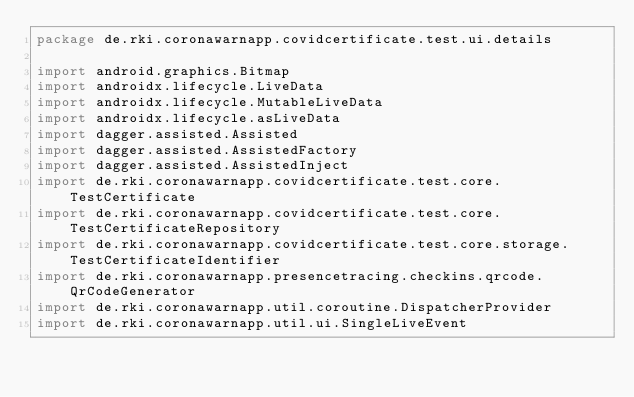Convert code to text. <code><loc_0><loc_0><loc_500><loc_500><_Kotlin_>package de.rki.coronawarnapp.covidcertificate.test.ui.details

import android.graphics.Bitmap
import androidx.lifecycle.LiveData
import androidx.lifecycle.MutableLiveData
import androidx.lifecycle.asLiveData
import dagger.assisted.Assisted
import dagger.assisted.AssistedFactory
import dagger.assisted.AssistedInject
import de.rki.coronawarnapp.covidcertificate.test.core.TestCertificate
import de.rki.coronawarnapp.covidcertificate.test.core.TestCertificateRepository
import de.rki.coronawarnapp.covidcertificate.test.core.storage.TestCertificateIdentifier
import de.rki.coronawarnapp.presencetracing.checkins.qrcode.QrCodeGenerator
import de.rki.coronawarnapp.util.coroutine.DispatcherProvider
import de.rki.coronawarnapp.util.ui.SingleLiveEvent</code> 